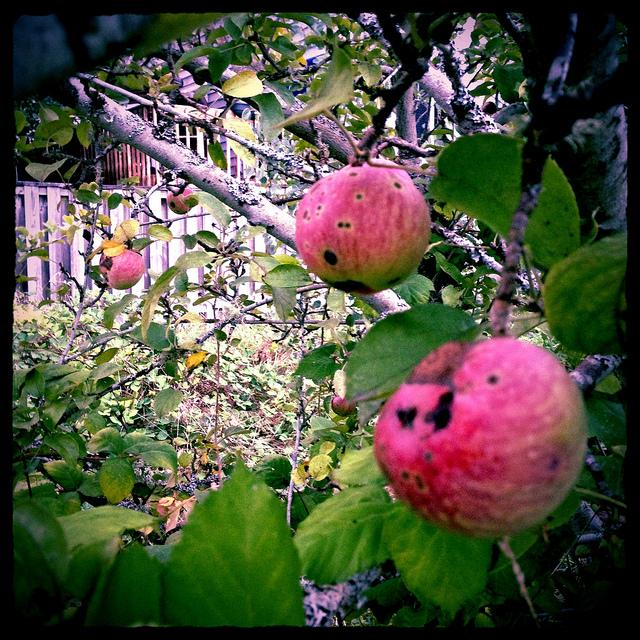Why are there black spots on the apples? Please explain your reasoning. rotting. They have been on the tree too long and are getting moldy. 